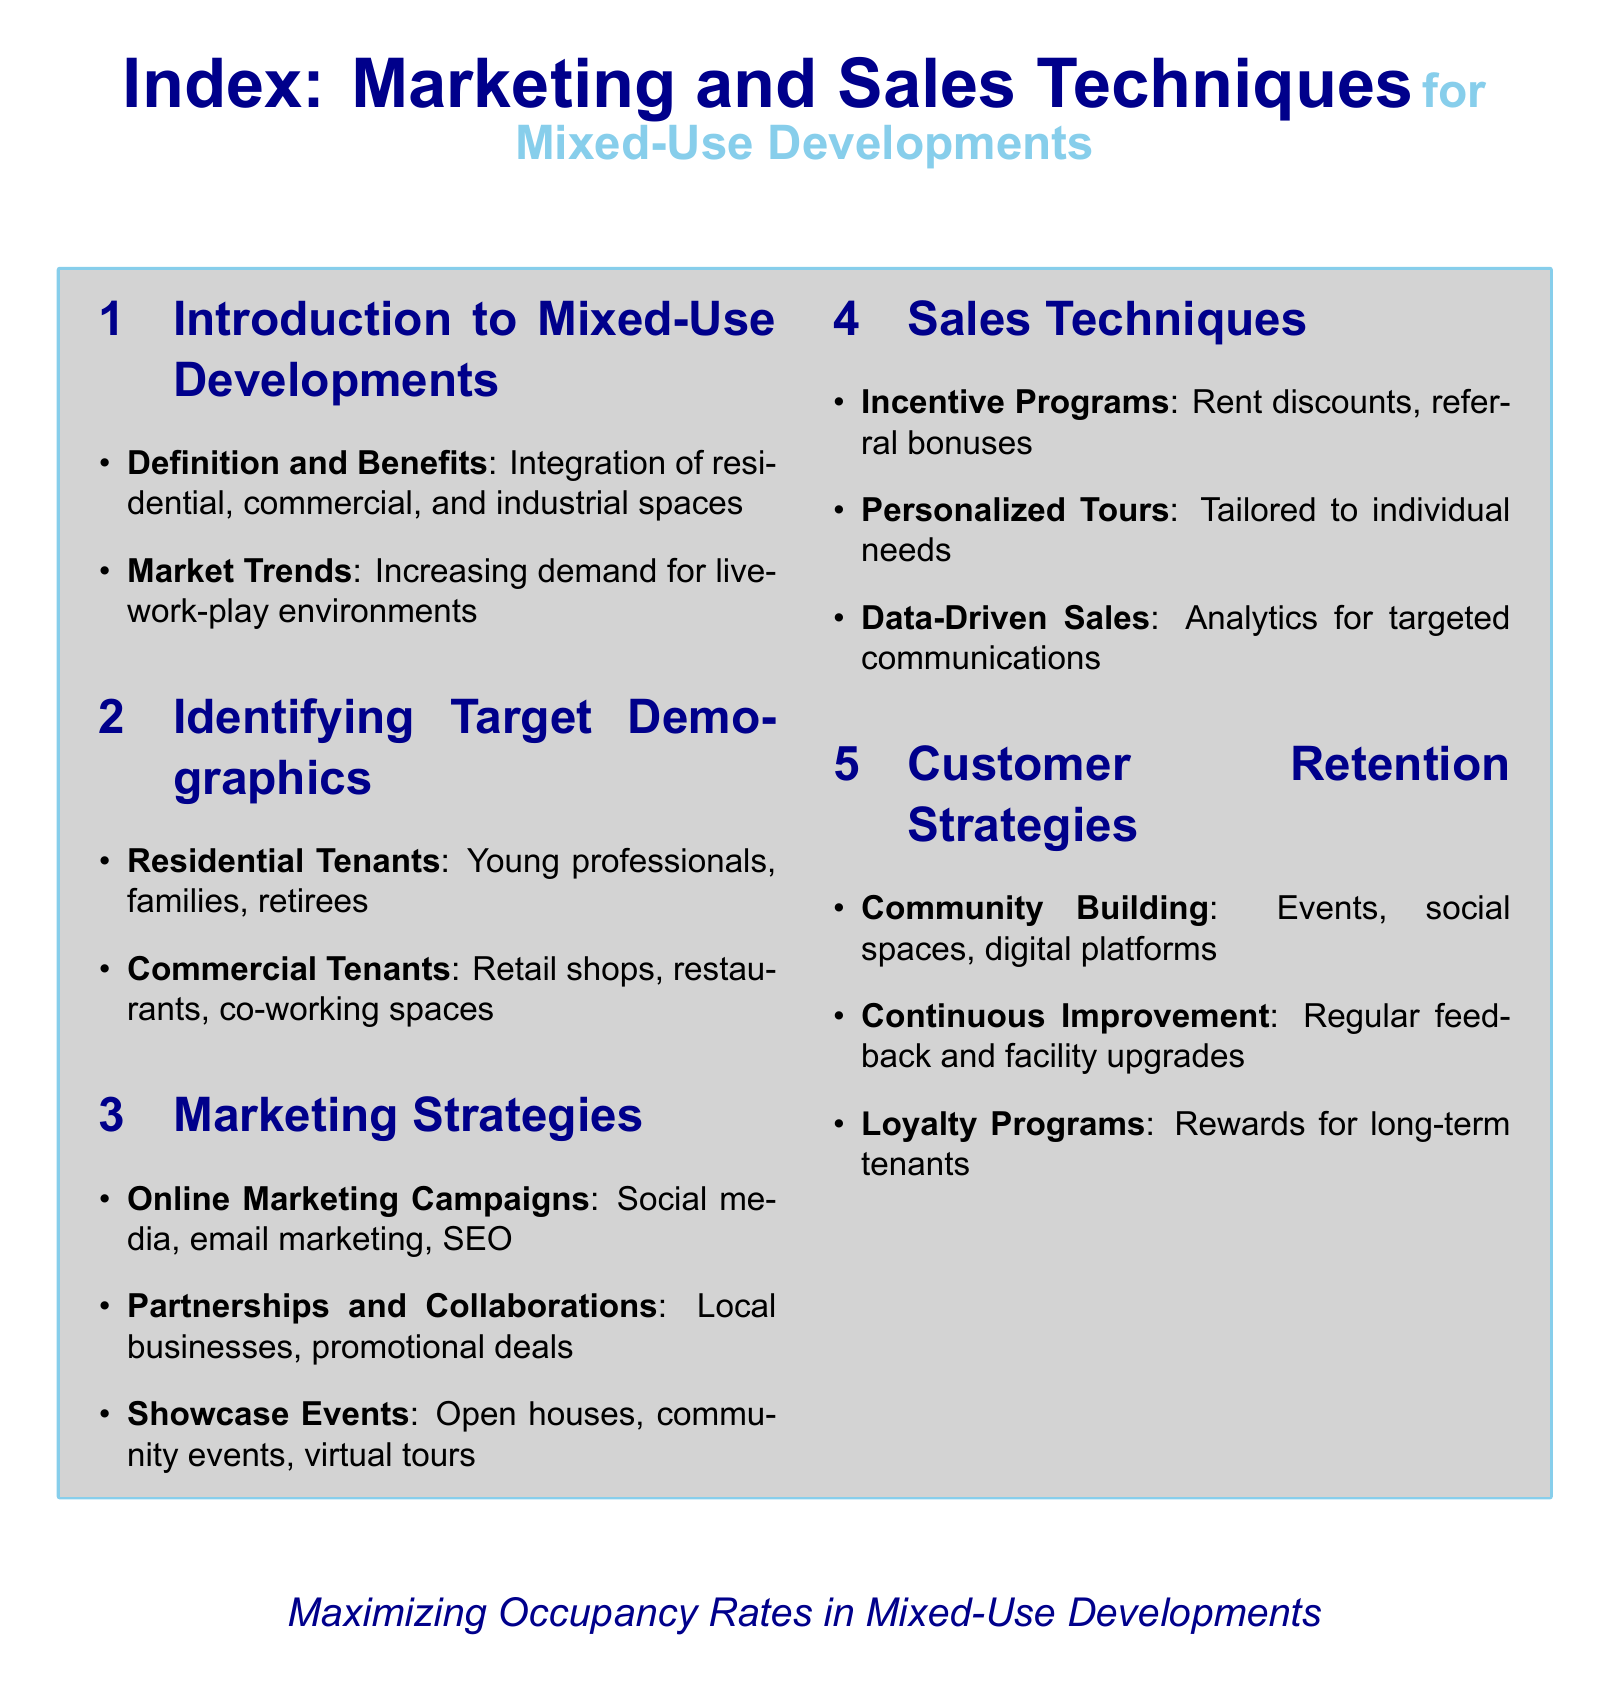What is the main focus of the document? The document centers on marketing and sales techniques for mixed-use developments.
Answer: Marketing and sales techniques for mixed-use developments Who are the target residential tenants mentioned? The document lists young professionals, families, and retirees as target residential tenants.
Answer: Young professionals, families, retirees What type of tenants does the document identify for commercial spaces? Retail shops, restaurants, and co-working spaces are identified as target commercial tenants.
Answer: Retail shops, restaurants, co-working spaces What strategy involves social media and email marketing? Online marketing campaigns are described as involving social media, email marketing, and SEO.
Answer: Online marketing campaigns What does the document suggest using for analytics in sales? Data-driven sales techniques utilize analytics for targeted communications.
Answer: Analytics for targeted communications How many customer retention strategies are listed? Three customer retention strategies are detailed in the document.
Answer: Three What is suggested for community engagement? Community building involves events, social spaces, and digital platforms.
Answer: Events, social spaces, digital platforms What kind of events are recommended for showcasing spaces? Open houses, community events, and virtual tours are recommended.
Answer: Open houses, community events, virtual tours What type of program is incentivized for tenant referrals? Incentive programs including rent discounts and referral bonuses are mentioned.
Answer: Rent discounts, referral bonuses 